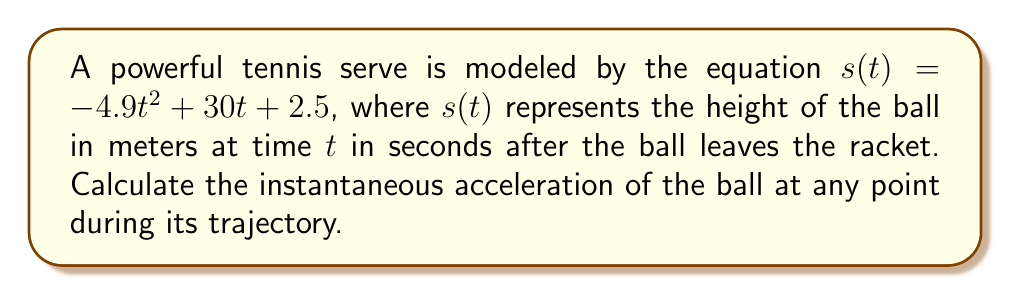Give your solution to this math problem. To find the instantaneous acceleration of the tennis ball, we need to take the second derivative of the position function $s(t)$.

1. Start with the given position function:
   $s(t) = -4.9t^2 + 30t + 2.5$

2. Find the velocity function by taking the first derivative:
   $v(t) = s'(t) = \frac{d}{dt}(-4.9t^2 + 30t + 2.5)$
   $v(t) = -9.8t + 30$

3. Find the acceleration function by taking the second derivative:
   $a(t) = v'(t) = \frac{d}{dt}(-9.8t + 30)$
   $a(t) = -9.8$

The acceleration is constant and equal to -9.8 m/s², which is the acceleration due to gravity on Earth (rounded to one decimal place). This makes sense physically, as once the ball leaves the racket, the only force acting on it is gravity (ignoring air resistance).

Note that the negative sign indicates that the acceleration is downward, opposing the upward motion of the ball.
Answer: $a(t) = -9.8$ m/s² 